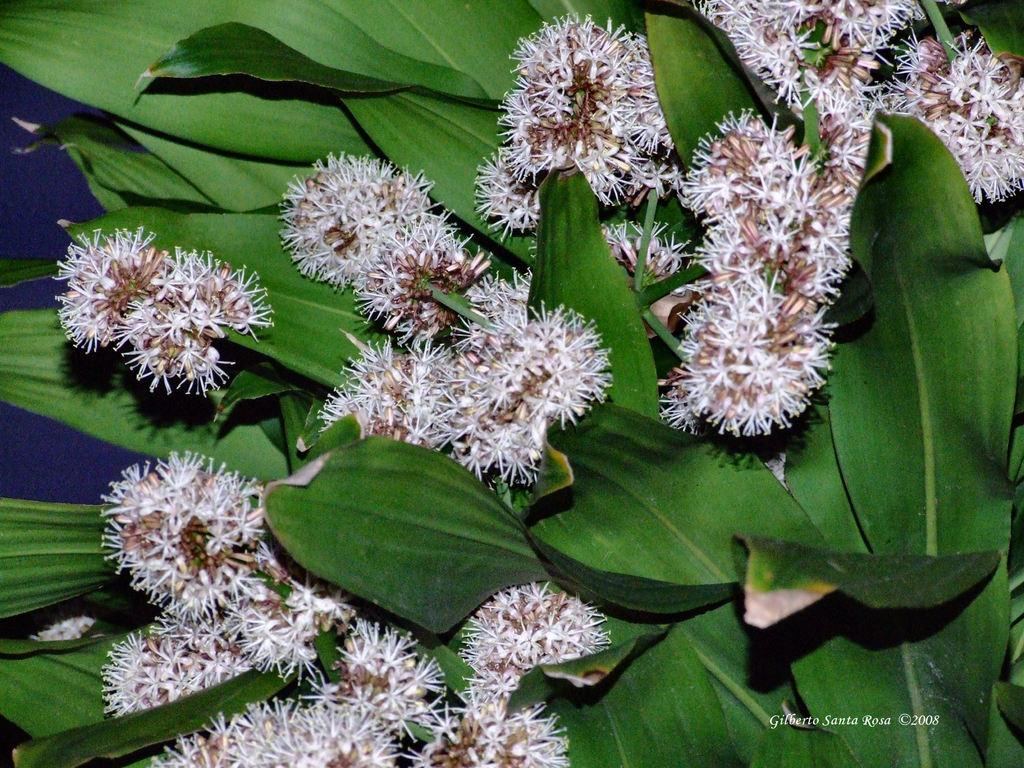What type of living organism is present in the image? There is a plant in the image. What color are the leaves of the plant? The leaves of the plant are green. What additional features can be seen on the plant? The plant has flowers. What type of nut is used to hold the quilt together in the image? There is no nut or quilt present in the image; it features a plant with green leaves and flowers. 